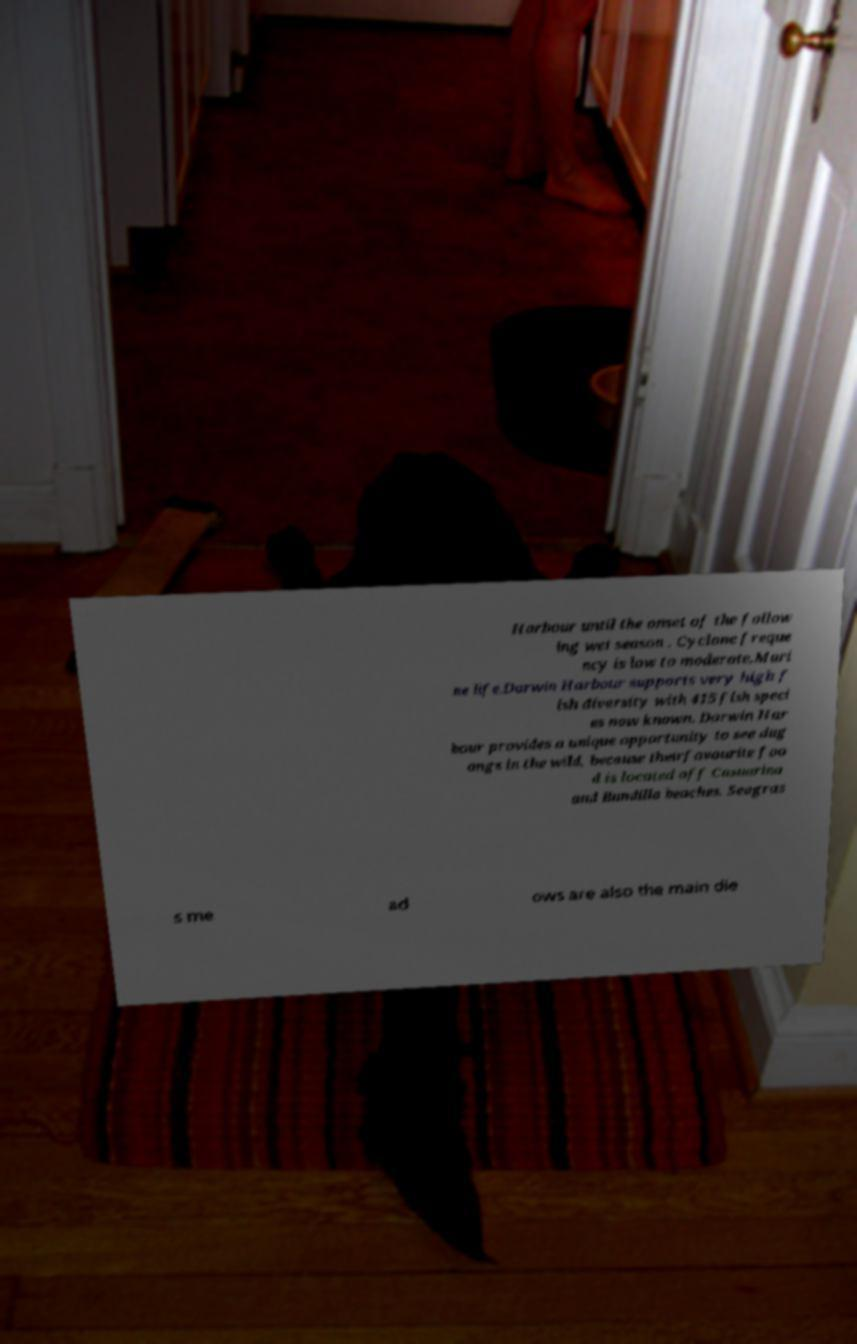I need the written content from this picture converted into text. Can you do that? Harbour until the onset of the follow ing wet season . Cyclone freque ncy is low to moderate.Mari ne life.Darwin Harbour supports very high f ish diversity with 415 fish speci es now known. Darwin Har bour provides a unique opportunity to see dug ongs in the wild, because theirfavourite foo d is located off Casuarina and Bundilla beaches. Seagras s me ad ows are also the main die 